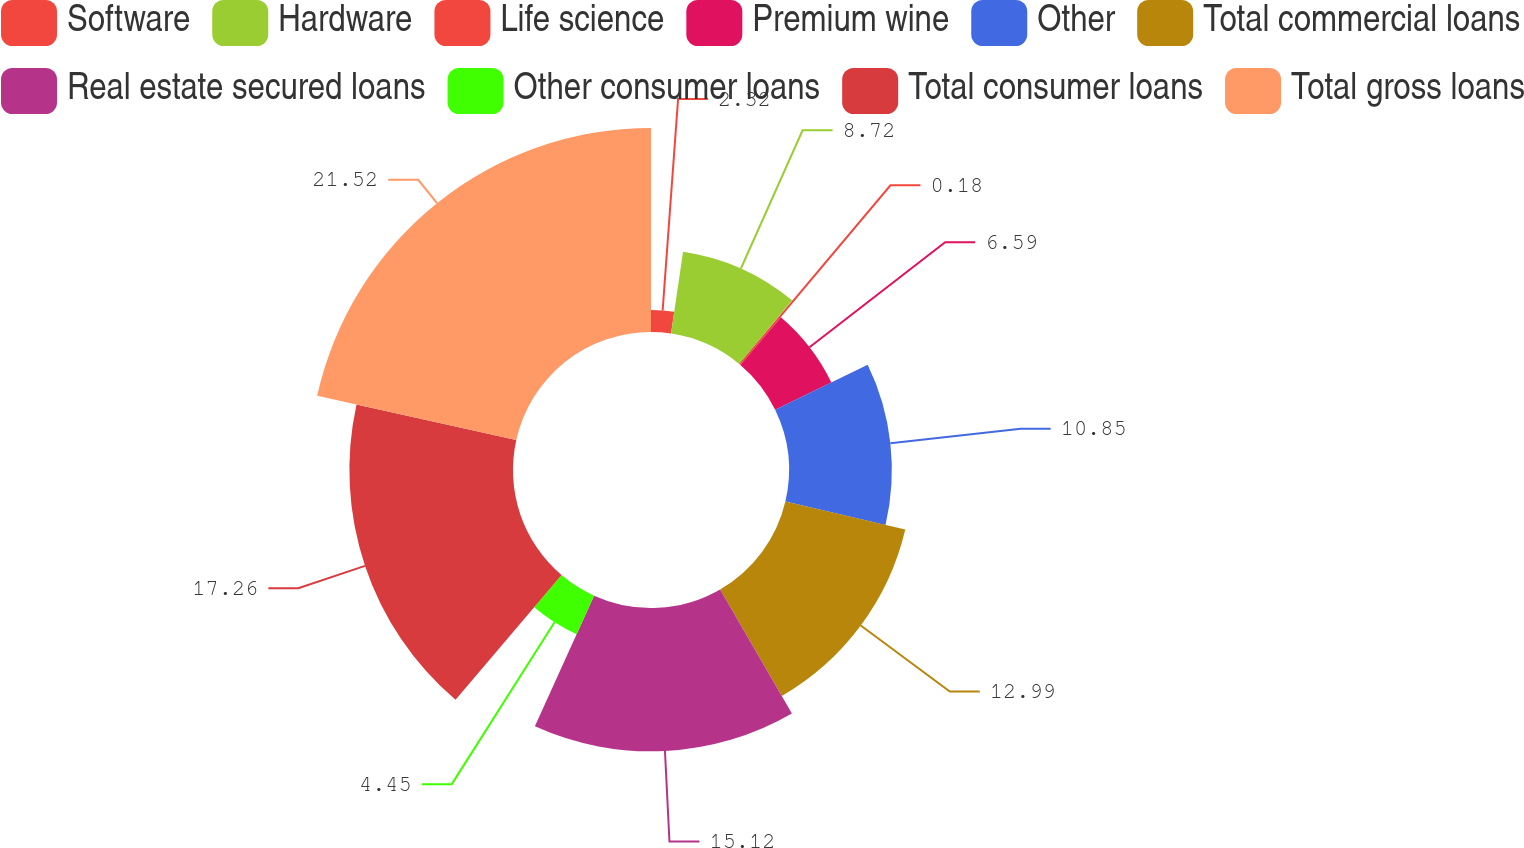Convert chart to OTSL. <chart><loc_0><loc_0><loc_500><loc_500><pie_chart><fcel>Software<fcel>Hardware<fcel>Life science<fcel>Premium wine<fcel>Other<fcel>Total commercial loans<fcel>Real estate secured loans<fcel>Other consumer loans<fcel>Total consumer loans<fcel>Total gross loans<nl><fcel>2.32%<fcel>8.72%<fcel>0.18%<fcel>6.59%<fcel>10.85%<fcel>12.99%<fcel>15.12%<fcel>4.45%<fcel>17.26%<fcel>21.52%<nl></chart> 